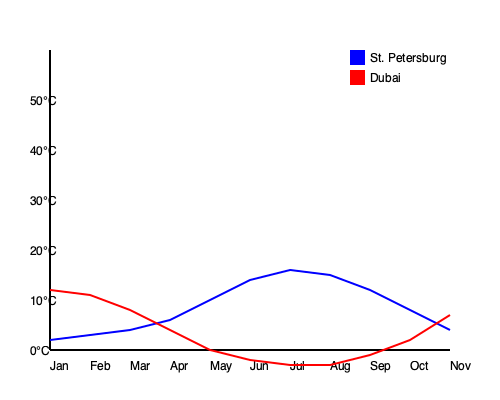Based on the line graph comparing the average monthly temperatures of St. Petersburg and Dubai, during which month does St. Petersburg experience its highest average temperature, and how does it compare to Dubai's temperature in the same month? To answer this question, we need to follow these steps:

1. Identify St. Petersburg's line on the graph (blue line).
2. Find the highest point on St. Petersburg's line.
3. Determine which month this highest point corresponds to.
4. Compare this point to Dubai's temperature (red line) for the same month.

Step-by-step analysis:
1. The blue line represents St. Petersburg's temperatures.
2. The highest point on the blue line is in July (7th month from left).
3. July is when St. Petersburg experiences its highest average temperature.
4. In July:
   - St. Petersburg's temperature is approximately 22°C (blue line)
   - Dubai's temperature is approximately 41°C (red line)
5. The difference between the two temperatures in July is about 19°C (41°C - 22°C).

Therefore, St. Petersburg's highest average temperature occurs in July, and it is approximately 19°C lower than Dubai's temperature in the same month.
Answer: July; 19°C lower than Dubai 